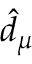Convert formula to latex. <formula><loc_0><loc_0><loc_500><loc_500>\hat { d } _ { \mu }</formula> 